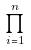Convert formula to latex. <formula><loc_0><loc_0><loc_500><loc_500>\prod _ { i = 1 } ^ { n }</formula> 